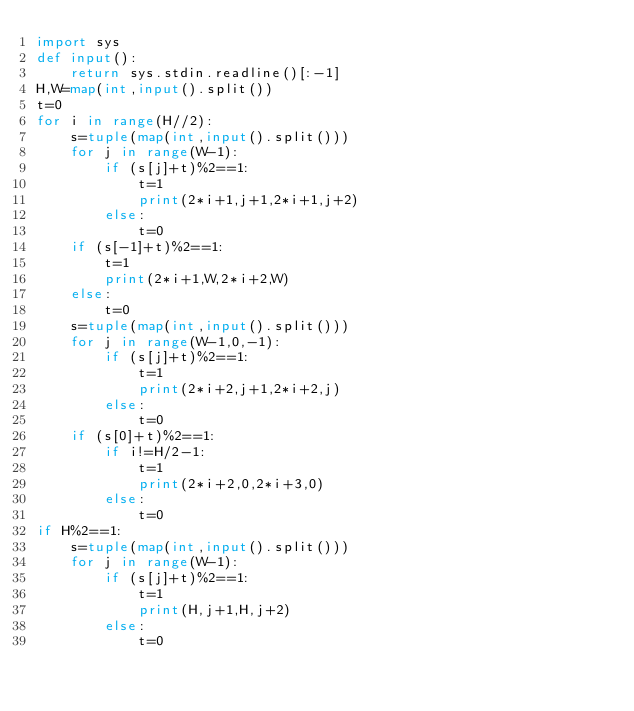<code> <loc_0><loc_0><loc_500><loc_500><_Python_>import sys
def input():
    return sys.stdin.readline()[:-1]
H,W=map(int,input().split())
t=0
for i in range(H//2):
    s=tuple(map(int,input().split()))
    for j in range(W-1):
        if (s[j]+t)%2==1:
            t=1
            print(2*i+1,j+1,2*i+1,j+2)
        else:
            t=0
    if (s[-1]+t)%2==1:
        t=1
        print(2*i+1,W,2*i+2,W)
    else:
        t=0
    s=tuple(map(int,input().split()))
    for j in range(W-1,0,-1):
        if (s[j]+t)%2==1:
            t=1
            print(2*i+2,j+1,2*i+2,j)
        else:
            t=0
    if (s[0]+t)%2==1:
        if i!=H/2-1:
            t=1
            print(2*i+2,0,2*i+3,0)
        else:
            t=0
if H%2==1:
    s=tuple(map(int,input().split()))
    for j in range(W-1):
        if (s[j]+t)%2==1:
            t=1
            print(H,j+1,H,j+2)
        else:
            t=0</code> 